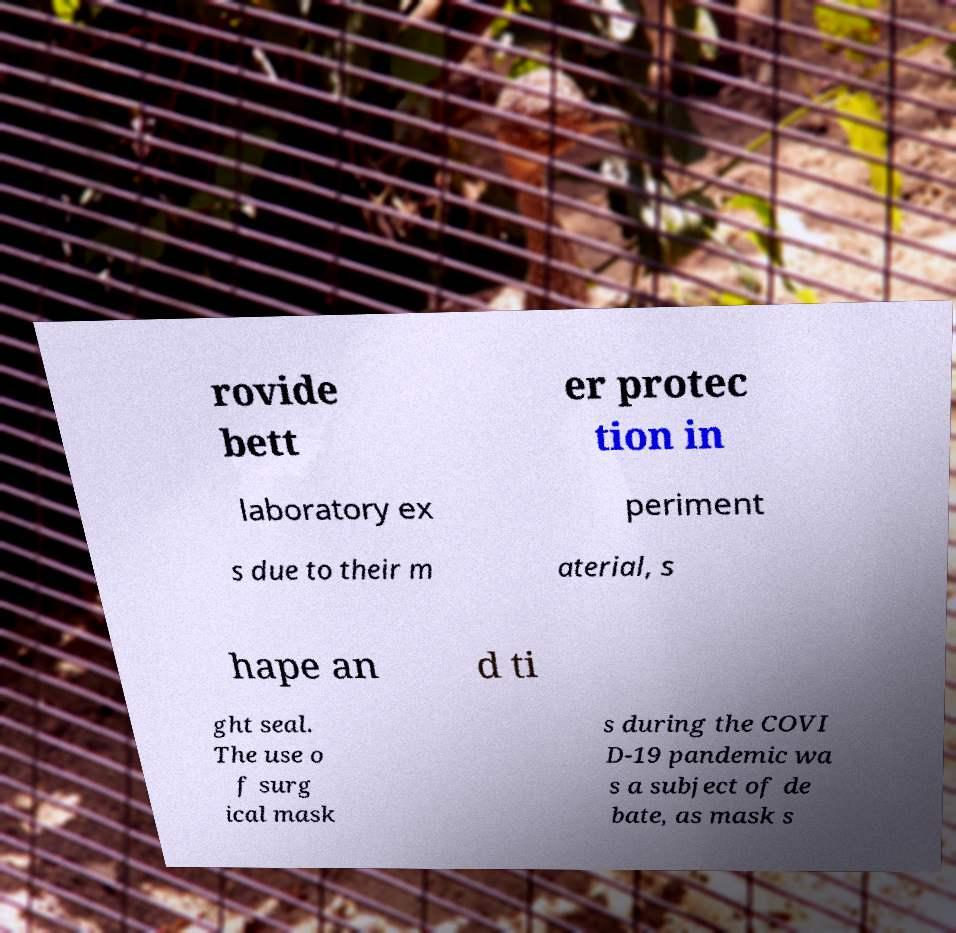What messages or text are displayed in this image? I need them in a readable, typed format. rovide bett er protec tion in laboratory ex periment s due to their m aterial, s hape an d ti ght seal. The use o f surg ical mask s during the COVI D-19 pandemic wa s a subject of de bate, as mask s 